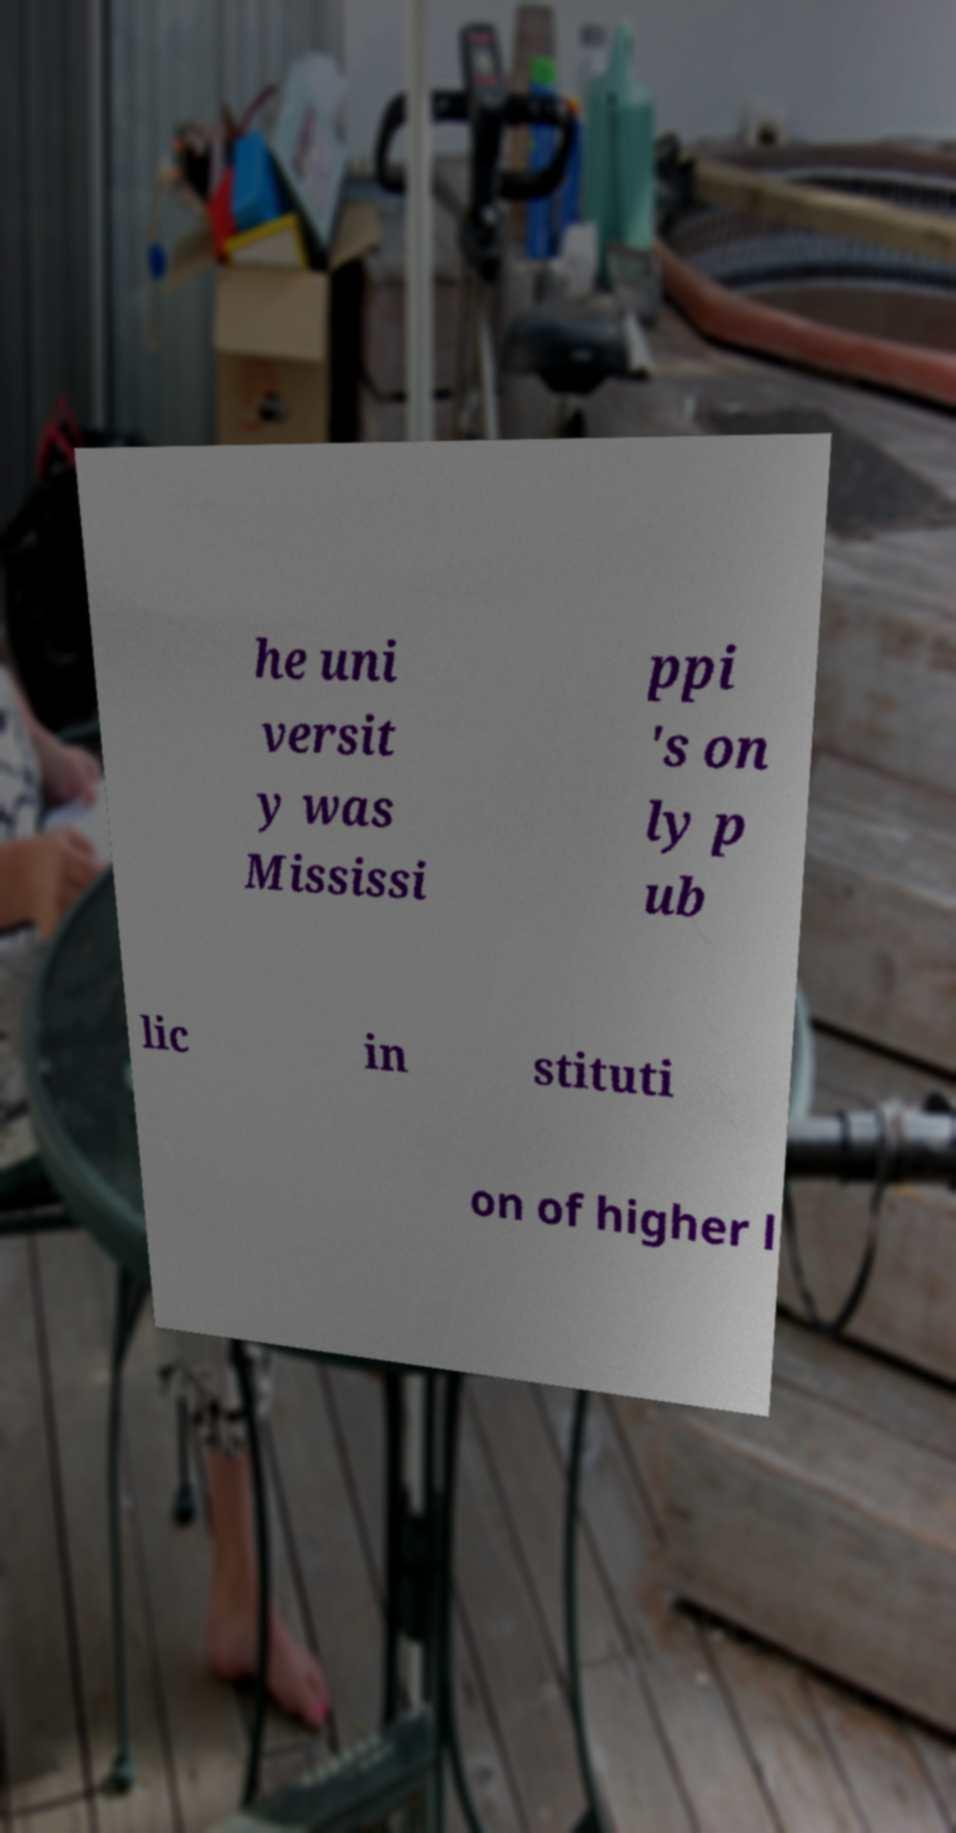I need the written content from this picture converted into text. Can you do that? he uni versit y was Mississi ppi 's on ly p ub lic in stituti on of higher l 